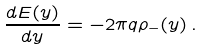Convert formula to latex. <formula><loc_0><loc_0><loc_500><loc_500>\frac { d E ( y ) } { d y } = - 2 \pi q \rho _ { - } ( y ) \, .</formula> 